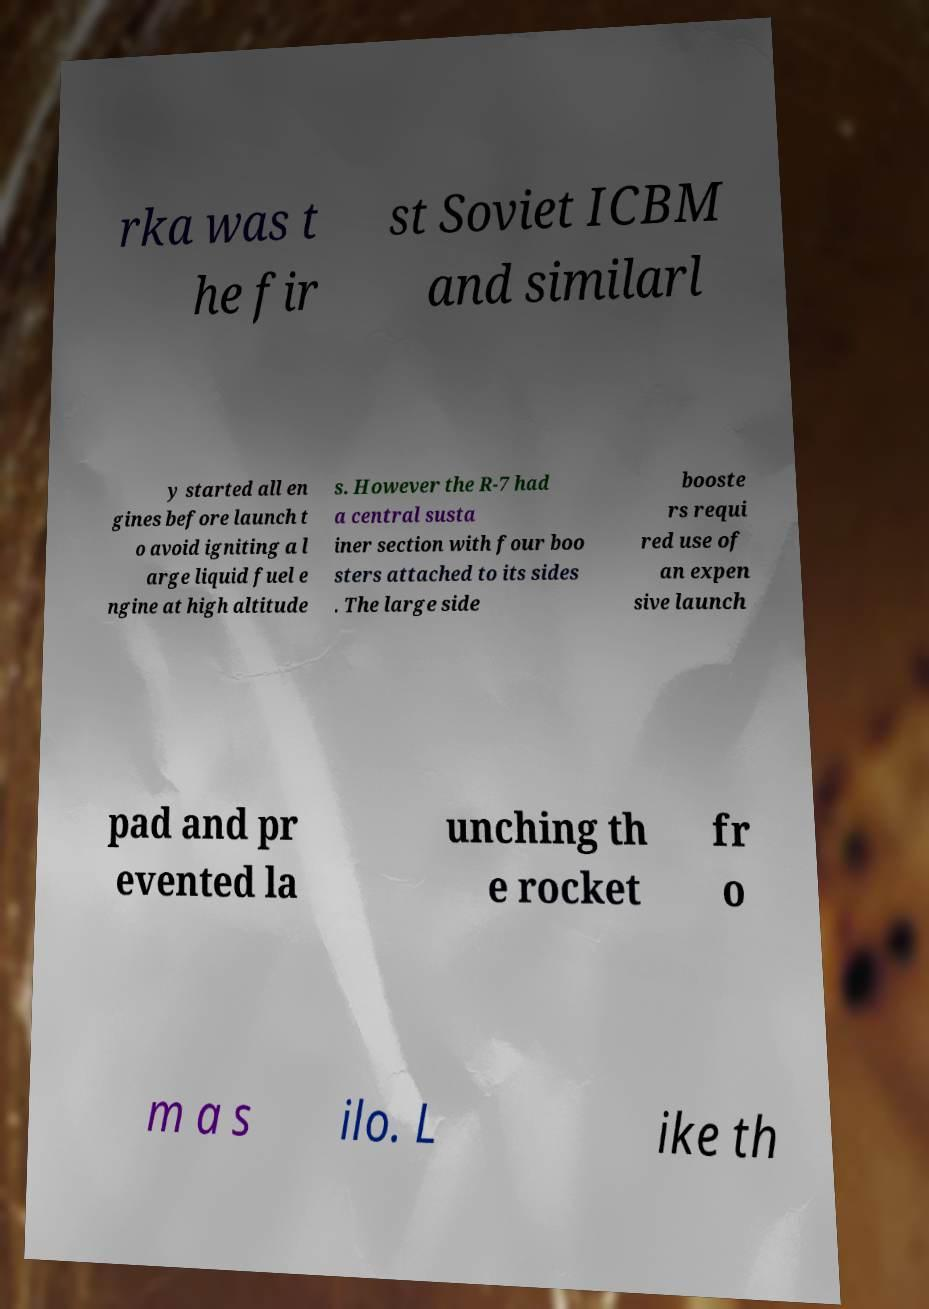I need the written content from this picture converted into text. Can you do that? rka was t he fir st Soviet ICBM and similarl y started all en gines before launch t o avoid igniting a l arge liquid fuel e ngine at high altitude s. However the R-7 had a central susta iner section with four boo sters attached to its sides . The large side booste rs requi red use of an expen sive launch pad and pr evented la unching th e rocket fr o m a s ilo. L ike th 